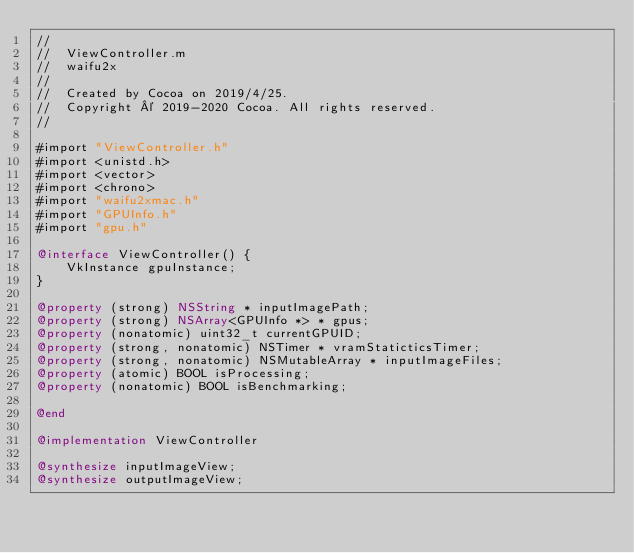<code> <loc_0><loc_0><loc_500><loc_500><_ObjectiveC_>//
//  ViewController.m
//  waifu2x
//
//  Created by Cocoa on 2019/4/25.
//  Copyright © 2019-2020 Cocoa. All rights reserved.
//

#import "ViewController.h"
#import <unistd.h>
#import <vector>
#import <chrono>
#import "waifu2xmac.h"
#import "GPUInfo.h"
#import "gpu.h"

@interface ViewController() {
    VkInstance gpuInstance;
}

@property (strong) NSString * inputImagePath;
@property (strong) NSArray<GPUInfo *> * gpus;
@property (nonatomic) uint32_t currentGPUID;
@property (strong, nonatomic) NSTimer * vramStaticticsTimer;
@property (strong, nonatomic) NSMutableArray * inputImageFiles;
@property (atomic) BOOL isProcessing;
@property (nonatomic) BOOL isBenchmarking;

@end

@implementation ViewController

@synthesize inputImageView;
@synthesize outputImageView;</code> 